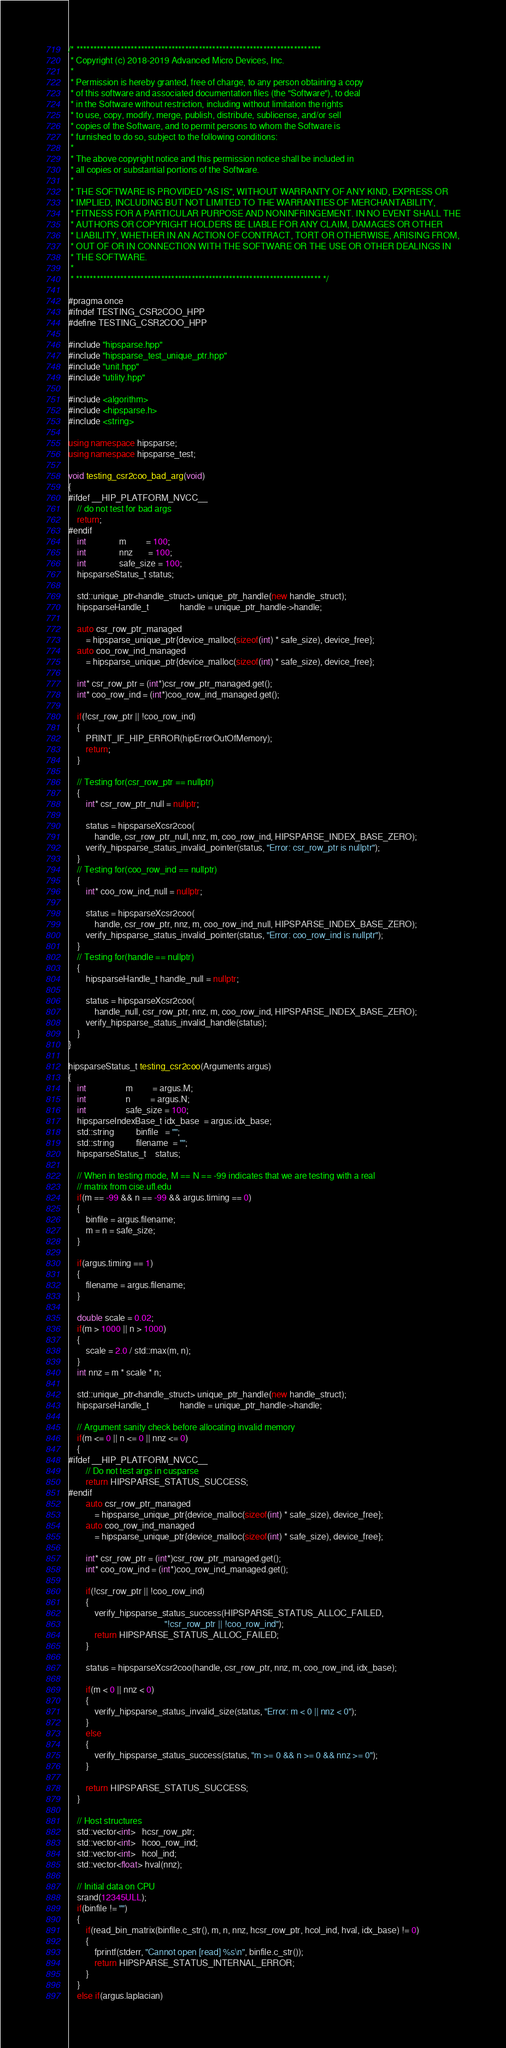<code> <loc_0><loc_0><loc_500><loc_500><_C++_>/* ************************************************************************
 * Copyright (c) 2018-2019 Advanced Micro Devices, Inc.
 *
 * Permission is hereby granted, free of charge, to any person obtaining a copy
 * of this software and associated documentation files (the "Software"), to deal
 * in the Software without restriction, including without limitation the rights
 * to use, copy, modify, merge, publish, distribute, sublicense, and/or sell
 * copies of the Software, and to permit persons to whom the Software is
 * furnished to do so, subject to the following conditions:
 *
 * The above copyright notice and this permission notice shall be included in
 * all copies or substantial portions of the Software.
 *
 * THE SOFTWARE IS PROVIDED "AS IS", WITHOUT WARRANTY OF ANY KIND, EXPRESS OR
 * IMPLIED, INCLUDING BUT NOT LIMITED TO THE WARRANTIES OF MERCHANTABILITY,
 * FITNESS FOR A PARTICULAR PURPOSE AND NONINFRINGEMENT. IN NO EVENT SHALL THE
 * AUTHORS OR COPYRIGHT HOLDERS BE LIABLE FOR ANY CLAIM, DAMAGES OR OTHER
 * LIABILITY, WHETHER IN AN ACTION OF CONTRACT, TORT OR OTHERWISE, ARISING FROM,
 * OUT OF OR IN CONNECTION WITH THE SOFTWARE OR THE USE OR OTHER DEALINGS IN
 * THE SOFTWARE.
 *
 * ************************************************************************ */

#pragma once
#ifndef TESTING_CSR2COO_HPP
#define TESTING_CSR2COO_HPP

#include "hipsparse.hpp"
#include "hipsparse_test_unique_ptr.hpp"
#include "unit.hpp"
#include "utility.hpp"

#include <algorithm>
#include <hipsparse.h>
#include <string>

using namespace hipsparse;
using namespace hipsparse_test;

void testing_csr2coo_bad_arg(void)
{
#ifdef __HIP_PLATFORM_NVCC__
    // do not test for bad args
    return;
#endif
    int               m         = 100;
    int               nnz       = 100;
    int               safe_size = 100;
    hipsparseStatus_t status;

    std::unique_ptr<handle_struct> unique_ptr_handle(new handle_struct);
    hipsparseHandle_t              handle = unique_ptr_handle->handle;

    auto csr_row_ptr_managed
        = hipsparse_unique_ptr{device_malloc(sizeof(int) * safe_size), device_free};
    auto coo_row_ind_managed
        = hipsparse_unique_ptr{device_malloc(sizeof(int) * safe_size), device_free};

    int* csr_row_ptr = (int*)csr_row_ptr_managed.get();
    int* coo_row_ind = (int*)coo_row_ind_managed.get();

    if(!csr_row_ptr || !coo_row_ind)
    {
        PRINT_IF_HIP_ERROR(hipErrorOutOfMemory);
        return;
    }

    // Testing for(csr_row_ptr == nullptr)
    {
        int* csr_row_ptr_null = nullptr;

        status = hipsparseXcsr2coo(
            handle, csr_row_ptr_null, nnz, m, coo_row_ind, HIPSPARSE_INDEX_BASE_ZERO);
        verify_hipsparse_status_invalid_pointer(status, "Error: csr_row_ptr is nullptr");
    }
    // Testing for(coo_row_ind == nullptr)
    {
        int* coo_row_ind_null = nullptr;

        status = hipsparseXcsr2coo(
            handle, csr_row_ptr, nnz, m, coo_row_ind_null, HIPSPARSE_INDEX_BASE_ZERO);
        verify_hipsparse_status_invalid_pointer(status, "Error: coo_row_ind is nullptr");
    }
    // Testing for(handle == nullptr)
    {
        hipsparseHandle_t handle_null = nullptr;

        status = hipsparseXcsr2coo(
            handle_null, csr_row_ptr, nnz, m, coo_row_ind, HIPSPARSE_INDEX_BASE_ZERO);
        verify_hipsparse_status_invalid_handle(status);
    }
}

hipsparseStatus_t testing_csr2coo(Arguments argus)
{
    int                  m         = argus.M;
    int                  n         = argus.N;
    int                  safe_size = 100;
    hipsparseIndexBase_t idx_base  = argus.idx_base;
    std::string          binfile   = "";
    std::string          filename  = "";
    hipsparseStatus_t    status;

    // When in testing mode, M == N == -99 indicates that we are testing with a real
    // matrix from cise.ufl.edu
    if(m == -99 && n == -99 && argus.timing == 0)
    {
        binfile = argus.filename;
        m = n = safe_size;
    }

    if(argus.timing == 1)
    {
        filename = argus.filename;
    }

    double scale = 0.02;
    if(m > 1000 || n > 1000)
    {
        scale = 2.0 / std::max(m, n);
    }
    int nnz = m * scale * n;

    std::unique_ptr<handle_struct> unique_ptr_handle(new handle_struct);
    hipsparseHandle_t              handle = unique_ptr_handle->handle;

    // Argument sanity check before allocating invalid memory
    if(m <= 0 || n <= 0 || nnz <= 0)
    {
#ifdef __HIP_PLATFORM_NVCC__
        // Do not test args in cusparse
        return HIPSPARSE_STATUS_SUCCESS;
#endif
        auto csr_row_ptr_managed
            = hipsparse_unique_ptr{device_malloc(sizeof(int) * safe_size), device_free};
        auto coo_row_ind_managed
            = hipsparse_unique_ptr{device_malloc(sizeof(int) * safe_size), device_free};

        int* csr_row_ptr = (int*)csr_row_ptr_managed.get();
        int* coo_row_ind = (int*)coo_row_ind_managed.get();

        if(!csr_row_ptr || !coo_row_ind)
        {
            verify_hipsparse_status_success(HIPSPARSE_STATUS_ALLOC_FAILED,
                                            "!csr_row_ptr || !coo_row_ind");
            return HIPSPARSE_STATUS_ALLOC_FAILED;
        }

        status = hipsparseXcsr2coo(handle, csr_row_ptr, nnz, m, coo_row_ind, idx_base);

        if(m < 0 || nnz < 0)
        {
            verify_hipsparse_status_invalid_size(status, "Error: m < 0 || nnz < 0");
        }
        else
        {
            verify_hipsparse_status_success(status, "m >= 0 && n >= 0 && nnz >= 0");
        }

        return HIPSPARSE_STATUS_SUCCESS;
    }

    // Host structures
    std::vector<int>   hcsr_row_ptr;
    std::vector<int>   hcoo_row_ind;
    std::vector<int>   hcol_ind;
    std::vector<float> hval(nnz);

    // Initial data on CPU
    srand(12345ULL);
    if(binfile != "")
    {
        if(read_bin_matrix(binfile.c_str(), m, n, nnz, hcsr_row_ptr, hcol_ind, hval, idx_base) != 0)
        {
            fprintf(stderr, "Cannot open [read] %s\n", binfile.c_str());
            return HIPSPARSE_STATUS_INTERNAL_ERROR;
        }
    }
    else if(argus.laplacian)</code> 